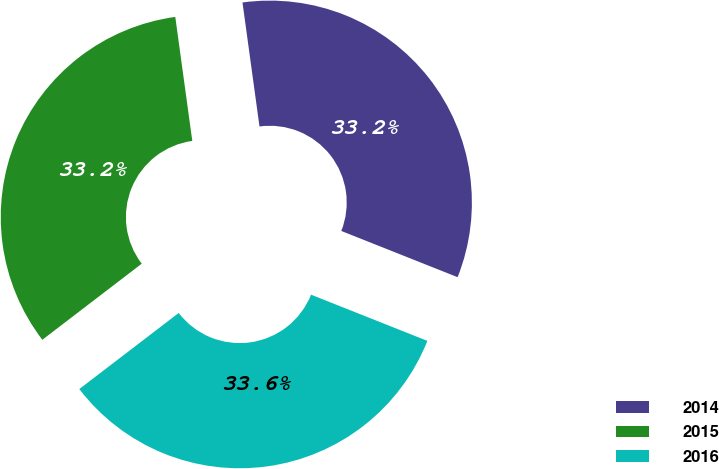Convert chart. <chart><loc_0><loc_0><loc_500><loc_500><pie_chart><fcel>2014<fcel>2015<fcel>2016<nl><fcel>33.19%<fcel>33.23%<fcel>33.58%<nl></chart> 